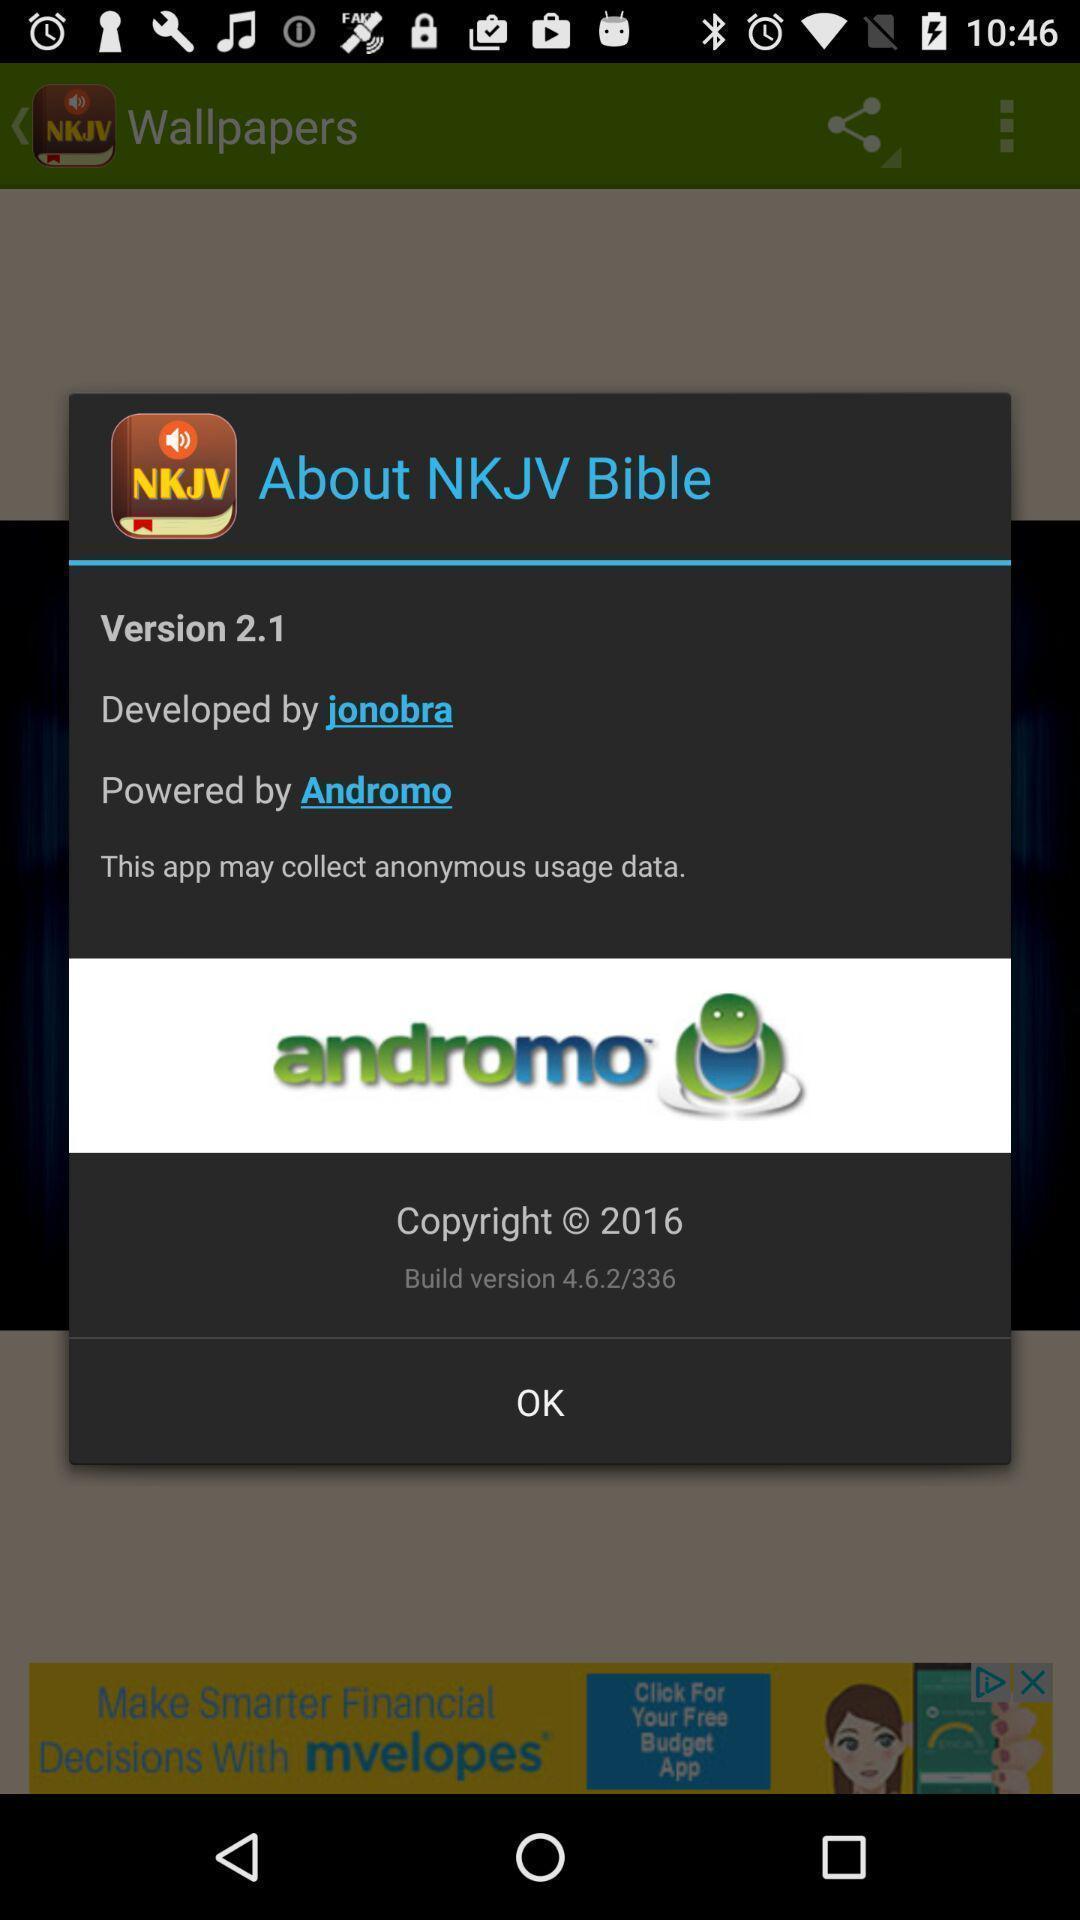Provide a textual representation of this image. Pop-up showing details about game. 